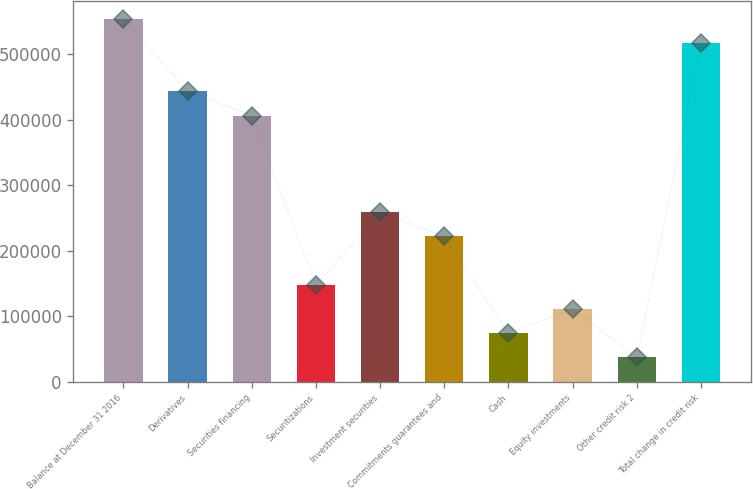<chart> <loc_0><loc_0><loc_500><loc_500><bar_chart><fcel>Balance at December 31 2016<fcel>Derivatives<fcel>Securities financing<fcel>Securitizations<fcel>Investment securities<fcel>Commitments guarantees and<fcel>Cash<fcel>Equity investments<fcel>Other credit risk 2<fcel>Total change in credit risk<nl><fcel>554347<fcel>443486<fcel>406532<fcel>147855<fcel>258717<fcel>221763<fcel>73947.6<fcel>110901<fcel>36993.8<fcel>517393<nl></chart> 